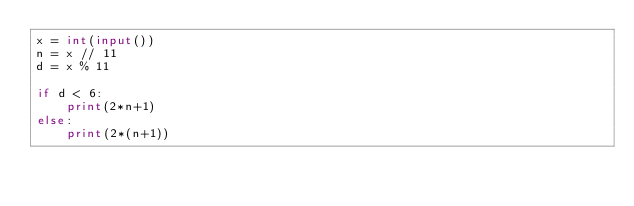Convert code to text. <code><loc_0><loc_0><loc_500><loc_500><_Python_>x = int(input())
n = x // 11
d = x % 11

if d < 6:
    print(2*n+1)
else:
    print(2*(n+1))</code> 